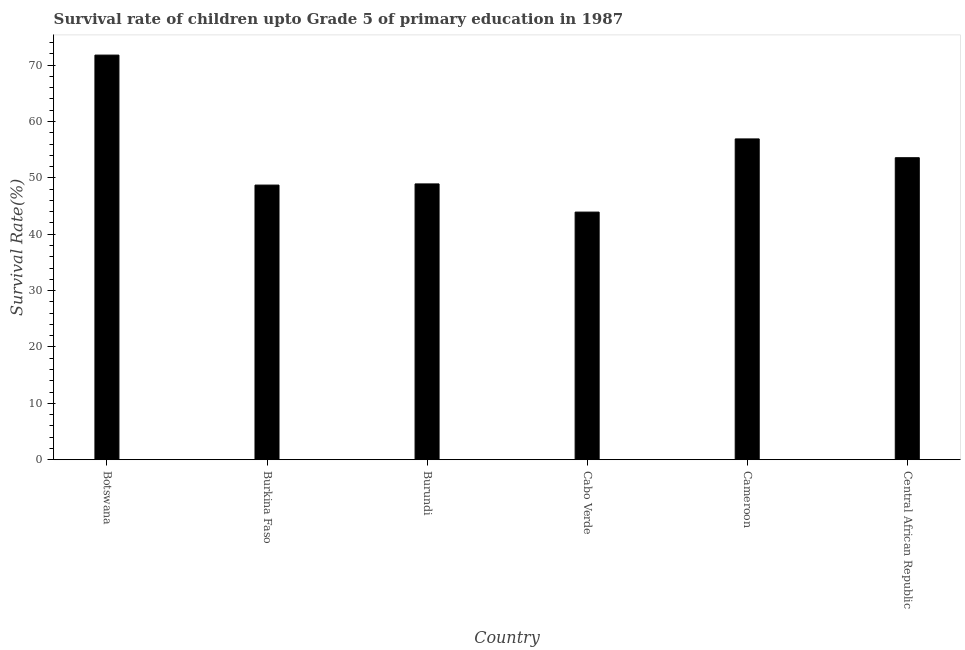What is the title of the graph?
Offer a very short reply. Survival rate of children upto Grade 5 of primary education in 1987 . What is the label or title of the X-axis?
Offer a very short reply. Country. What is the label or title of the Y-axis?
Provide a short and direct response. Survival Rate(%). What is the survival rate in Cabo Verde?
Provide a succinct answer. 43.93. Across all countries, what is the maximum survival rate?
Provide a succinct answer. 71.78. Across all countries, what is the minimum survival rate?
Your response must be concise. 43.93. In which country was the survival rate maximum?
Your answer should be compact. Botswana. In which country was the survival rate minimum?
Your answer should be compact. Cabo Verde. What is the sum of the survival rate?
Provide a short and direct response. 323.82. What is the difference between the survival rate in Cabo Verde and Cameroon?
Make the answer very short. -12.98. What is the average survival rate per country?
Offer a terse response. 53.97. What is the median survival rate?
Your response must be concise. 51.25. What is the ratio of the survival rate in Botswana to that in Cameroon?
Offer a very short reply. 1.26. What is the difference between the highest and the second highest survival rate?
Your answer should be very brief. 14.87. Is the sum of the survival rate in Cabo Verde and Cameroon greater than the maximum survival rate across all countries?
Your answer should be compact. Yes. What is the difference between the highest and the lowest survival rate?
Ensure brevity in your answer.  27.85. In how many countries, is the survival rate greater than the average survival rate taken over all countries?
Keep it short and to the point. 2. How many bars are there?
Offer a terse response. 6. Are the values on the major ticks of Y-axis written in scientific E-notation?
Your response must be concise. No. What is the Survival Rate(%) in Botswana?
Offer a very short reply. 71.78. What is the Survival Rate(%) of Burkina Faso?
Make the answer very short. 48.72. What is the Survival Rate(%) in Burundi?
Make the answer very short. 48.92. What is the Survival Rate(%) of Cabo Verde?
Ensure brevity in your answer.  43.93. What is the Survival Rate(%) of Cameroon?
Ensure brevity in your answer.  56.91. What is the Survival Rate(%) in Central African Republic?
Your answer should be very brief. 53.57. What is the difference between the Survival Rate(%) in Botswana and Burkina Faso?
Provide a succinct answer. 23.06. What is the difference between the Survival Rate(%) in Botswana and Burundi?
Make the answer very short. 22.85. What is the difference between the Survival Rate(%) in Botswana and Cabo Verde?
Ensure brevity in your answer.  27.85. What is the difference between the Survival Rate(%) in Botswana and Cameroon?
Your answer should be compact. 14.87. What is the difference between the Survival Rate(%) in Botswana and Central African Republic?
Your response must be concise. 18.2. What is the difference between the Survival Rate(%) in Burkina Faso and Burundi?
Your answer should be very brief. -0.21. What is the difference between the Survival Rate(%) in Burkina Faso and Cabo Verde?
Keep it short and to the point. 4.79. What is the difference between the Survival Rate(%) in Burkina Faso and Cameroon?
Keep it short and to the point. -8.19. What is the difference between the Survival Rate(%) in Burkina Faso and Central African Republic?
Your response must be concise. -4.86. What is the difference between the Survival Rate(%) in Burundi and Cabo Verde?
Your answer should be compact. 5. What is the difference between the Survival Rate(%) in Burundi and Cameroon?
Your answer should be compact. -7.98. What is the difference between the Survival Rate(%) in Burundi and Central African Republic?
Provide a succinct answer. -4.65. What is the difference between the Survival Rate(%) in Cabo Verde and Cameroon?
Keep it short and to the point. -12.98. What is the difference between the Survival Rate(%) in Cabo Verde and Central African Republic?
Your answer should be very brief. -9.65. What is the difference between the Survival Rate(%) in Cameroon and Central African Republic?
Ensure brevity in your answer.  3.33. What is the ratio of the Survival Rate(%) in Botswana to that in Burkina Faso?
Provide a short and direct response. 1.47. What is the ratio of the Survival Rate(%) in Botswana to that in Burundi?
Give a very brief answer. 1.47. What is the ratio of the Survival Rate(%) in Botswana to that in Cabo Verde?
Keep it short and to the point. 1.63. What is the ratio of the Survival Rate(%) in Botswana to that in Cameroon?
Make the answer very short. 1.26. What is the ratio of the Survival Rate(%) in Botswana to that in Central African Republic?
Your response must be concise. 1.34. What is the ratio of the Survival Rate(%) in Burkina Faso to that in Burundi?
Offer a terse response. 1. What is the ratio of the Survival Rate(%) in Burkina Faso to that in Cabo Verde?
Offer a terse response. 1.11. What is the ratio of the Survival Rate(%) in Burkina Faso to that in Cameroon?
Offer a terse response. 0.86. What is the ratio of the Survival Rate(%) in Burkina Faso to that in Central African Republic?
Provide a short and direct response. 0.91. What is the ratio of the Survival Rate(%) in Burundi to that in Cabo Verde?
Provide a succinct answer. 1.11. What is the ratio of the Survival Rate(%) in Burundi to that in Cameroon?
Offer a terse response. 0.86. What is the ratio of the Survival Rate(%) in Cabo Verde to that in Cameroon?
Offer a terse response. 0.77. What is the ratio of the Survival Rate(%) in Cabo Verde to that in Central African Republic?
Make the answer very short. 0.82. What is the ratio of the Survival Rate(%) in Cameroon to that in Central African Republic?
Make the answer very short. 1.06. 